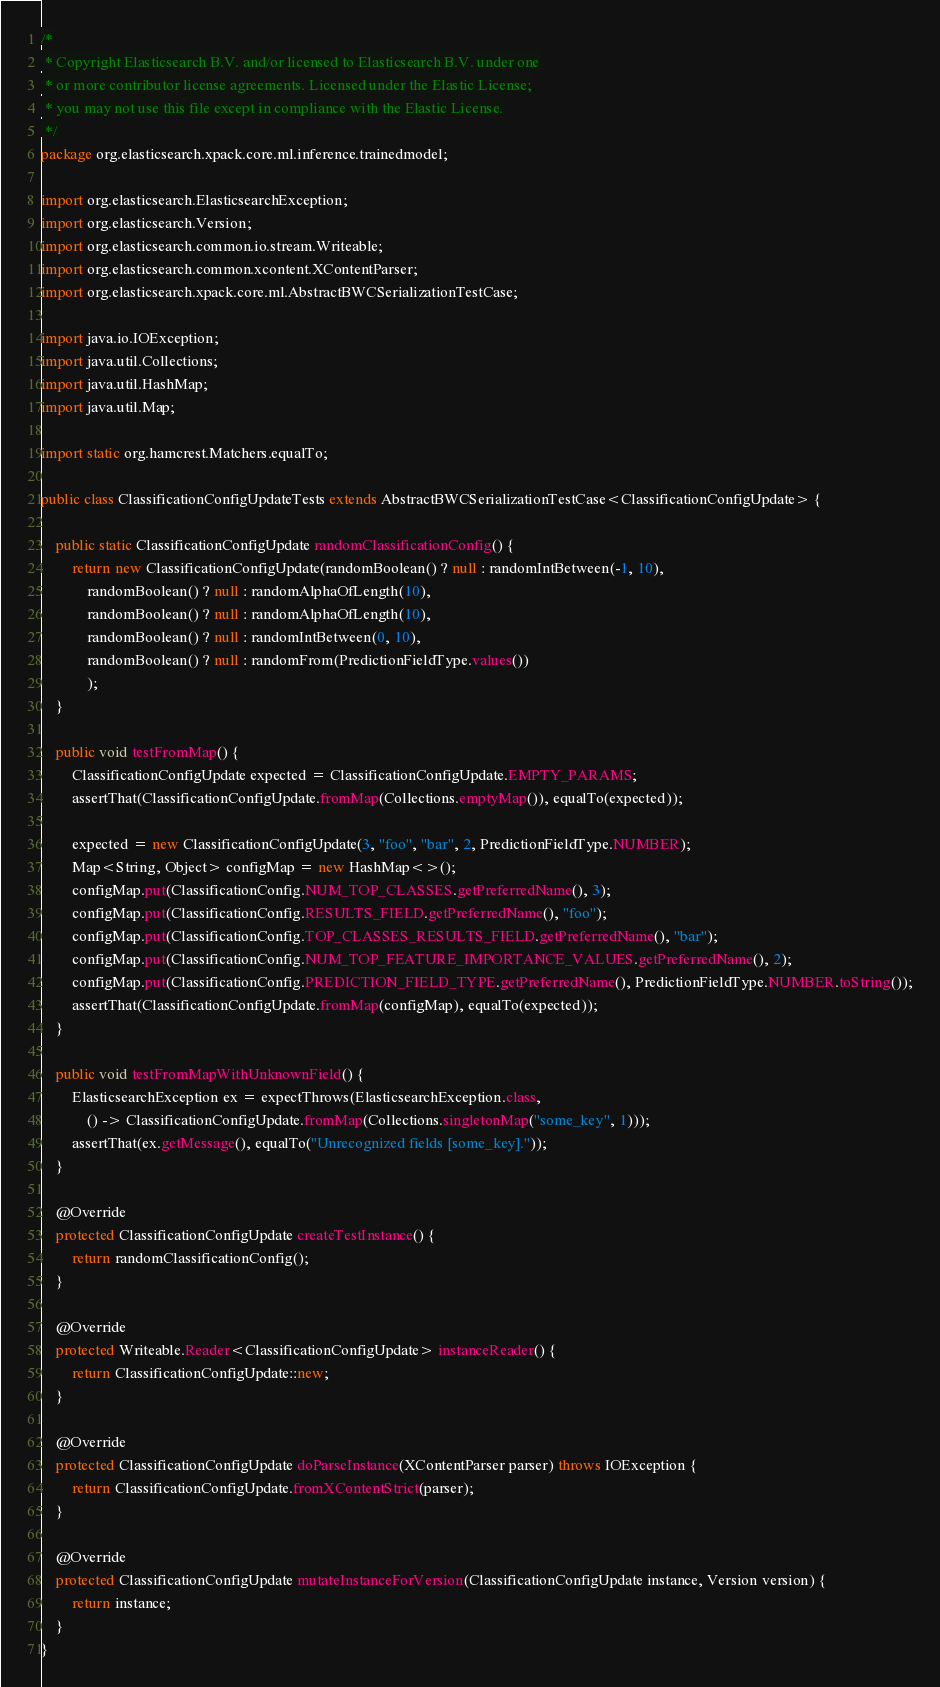Convert code to text. <code><loc_0><loc_0><loc_500><loc_500><_Java_>/*
 * Copyright Elasticsearch B.V. and/or licensed to Elasticsearch B.V. under one
 * or more contributor license agreements. Licensed under the Elastic License;
 * you may not use this file except in compliance with the Elastic License.
 */
package org.elasticsearch.xpack.core.ml.inference.trainedmodel;

import org.elasticsearch.ElasticsearchException;
import org.elasticsearch.Version;
import org.elasticsearch.common.io.stream.Writeable;
import org.elasticsearch.common.xcontent.XContentParser;
import org.elasticsearch.xpack.core.ml.AbstractBWCSerializationTestCase;

import java.io.IOException;
import java.util.Collections;
import java.util.HashMap;
import java.util.Map;

import static org.hamcrest.Matchers.equalTo;

public class ClassificationConfigUpdateTests extends AbstractBWCSerializationTestCase<ClassificationConfigUpdate> {

    public static ClassificationConfigUpdate randomClassificationConfig() {
        return new ClassificationConfigUpdate(randomBoolean() ? null : randomIntBetween(-1, 10),
            randomBoolean() ? null : randomAlphaOfLength(10),
            randomBoolean() ? null : randomAlphaOfLength(10),
            randomBoolean() ? null : randomIntBetween(0, 10),
            randomBoolean() ? null : randomFrom(PredictionFieldType.values())
            );
    }

    public void testFromMap() {
        ClassificationConfigUpdate expected = ClassificationConfigUpdate.EMPTY_PARAMS;
        assertThat(ClassificationConfigUpdate.fromMap(Collections.emptyMap()), equalTo(expected));

        expected = new ClassificationConfigUpdate(3, "foo", "bar", 2, PredictionFieldType.NUMBER);
        Map<String, Object> configMap = new HashMap<>();
        configMap.put(ClassificationConfig.NUM_TOP_CLASSES.getPreferredName(), 3);
        configMap.put(ClassificationConfig.RESULTS_FIELD.getPreferredName(), "foo");
        configMap.put(ClassificationConfig.TOP_CLASSES_RESULTS_FIELD.getPreferredName(), "bar");
        configMap.put(ClassificationConfig.NUM_TOP_FEATURE_IMPORTANCE_VALUES.getPreferredName(), 2);
        configMap.put(ClassificationConfig.PREDICTION_FIELD_TYPE.getPreferredName(), PredictionFieldType.NUMBER.toString());
        assertThat(ClassificationConfigUpdate.fromMap(configMap), equalTo(expected));
    }

    public void testFromMapWithUnknownField() {
        ElasticsearchException ex = expectThrows(ElasticsearchException.class,
            () -> ClassificationConfigUpdate.fromMap(Collections.singletonMap("some_key", 1)));
        assertThat(ex.getMessage(), equalTo("Unrecognized fields [some_key]."));
    }

    @Override
    protected ClassificationConfigUpdate createTestInstance() {
        return randomClassificationConfig();
    }

    @Override
    protected Writeable.Reader<ClassificationConfigUpdate> instanceReader() {
        return ClassificationConfigUpdate::new;
    }

    @Override
    protected ClassificationConfigUpdate doParseInstance(XContentParser parser) throws IOException {
        return ClassificationConfigUpdate.fromXContentStrict(parser);
    }

    @Override
    protected ClassificationConfigUpdate mutateInstanceForVersion(ClassificationConfigUpdate instance, Version version) {
        return instance;
    }
}
</code> 